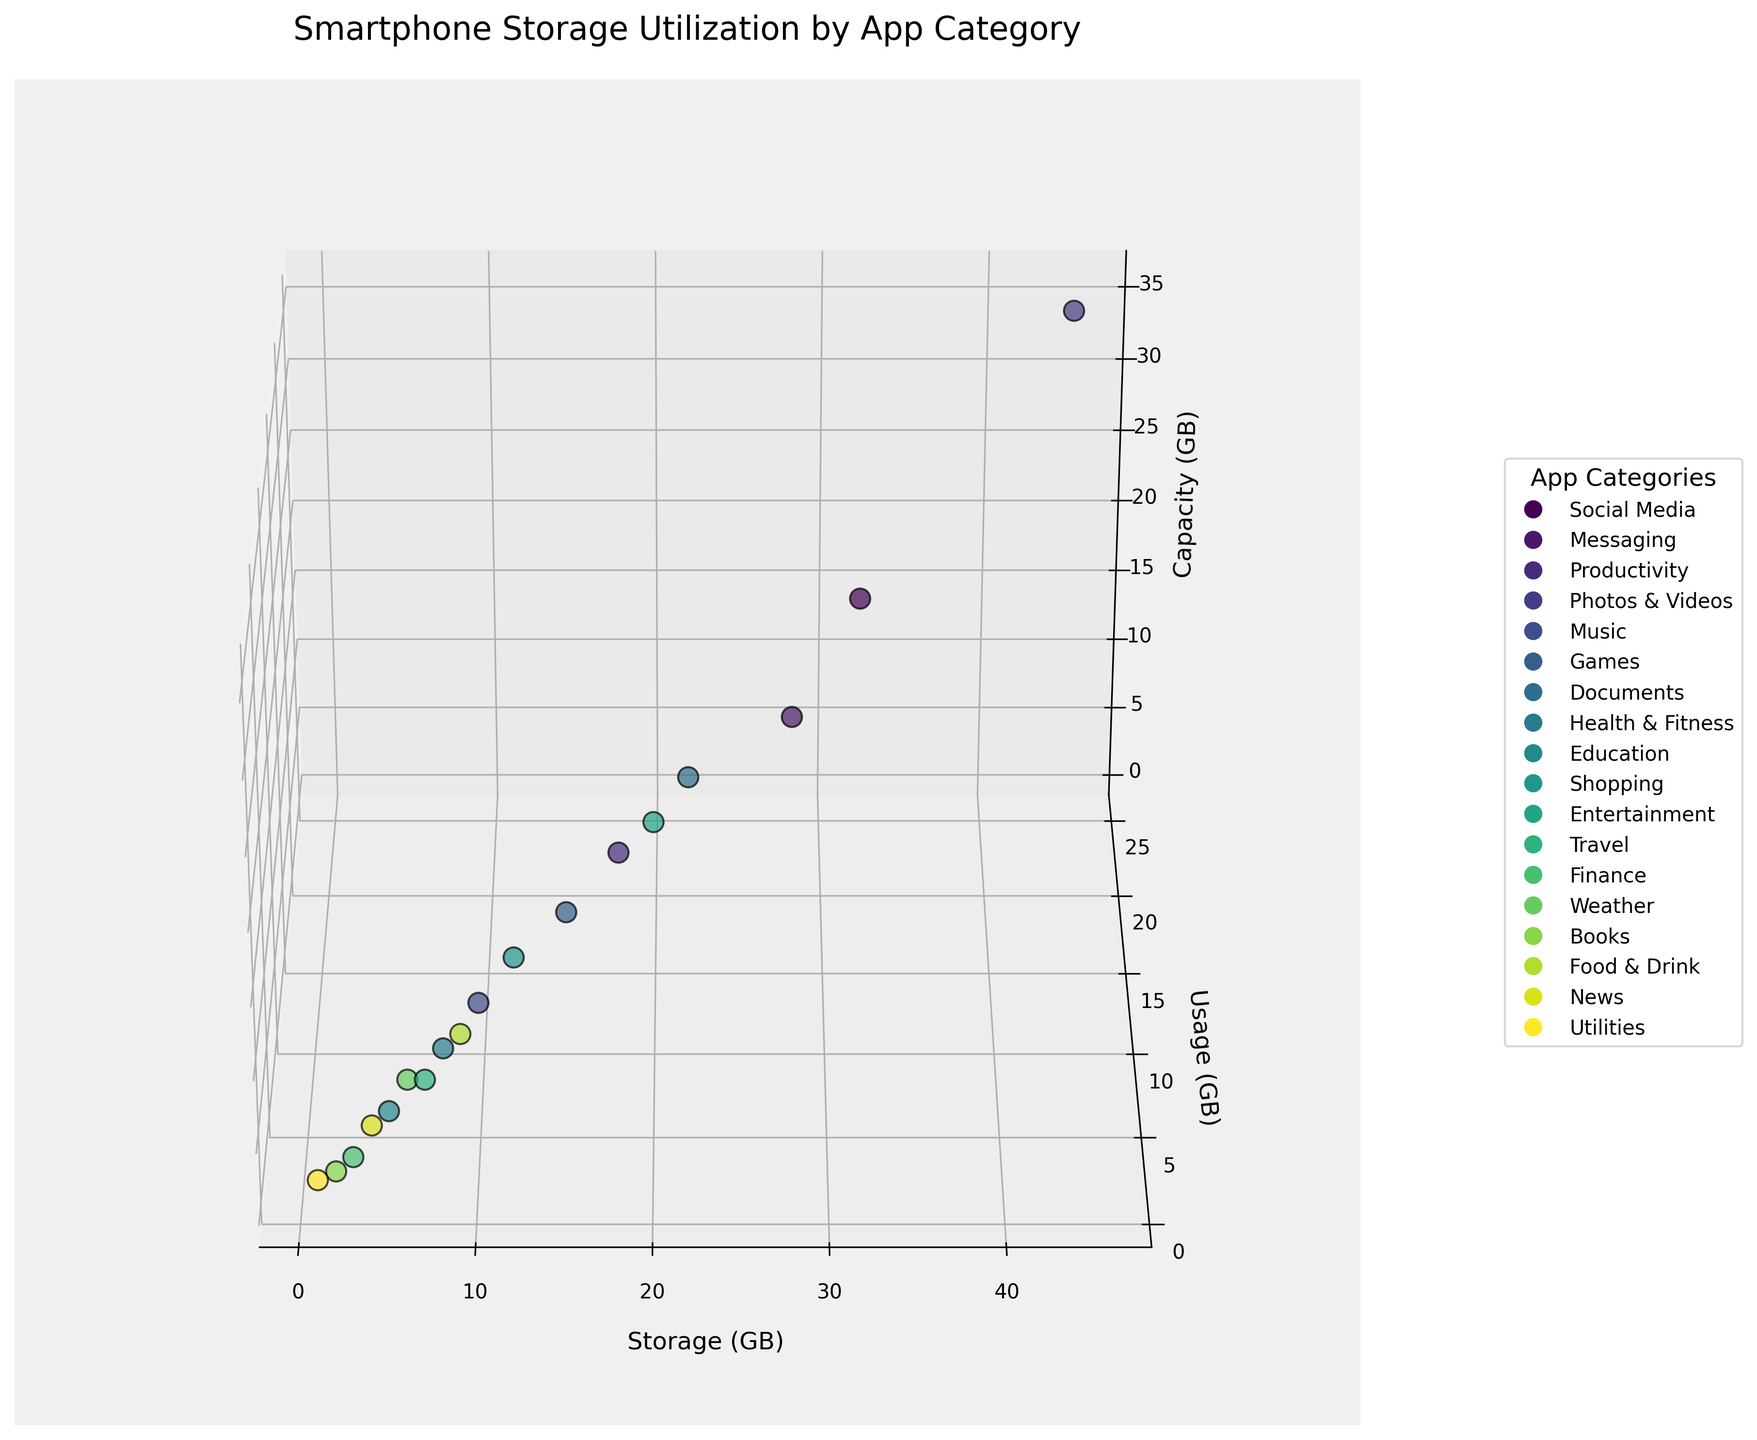What's the title of the figure? The title of the figure is located at the top of the plot, usually to provide a summary of what the plot is showing.
Answer: Smartphone Storage Utilization by App Category What are the axes labeled with? The axes labels provide information on what each axis represents in the figure. The x-axis is labeled "Storage (GB)," the y-axis is labeled "Usage (GB)," and the z-axis is labeled "Capacity (GB)."
Answer: Storage (GB), Usage (GB), Capacity (GB) How many data points are displayed in the figure? To find the number of data points, you can count the number of distinct points in the plot or refer to the categories given in the dataset.
Answer: 18 Which app category uses the most storage? Look for the category with the highest x-value, since storage is represented along the x-axis. "Photos & Videos" has the highest x-value of 45 GB.
Answer: Photos & Videos Compare the storage and usage between the "Social Media" and "Messaging" categories. For Social Media, the storage is 32 GB and usage is 15 GB. For Messaging, the storage is 28 GB and usage is 12 GB. Comparatively, Social Media uses 4 GB more storage and 3 GB more usage than Messaging.
Answer: Social Media uses more storage and usage What's the sum of storage for "Health & Fitness" and "Entertainment"? Add the storage values for "Health & Fitness" (8 GB) and "Entertainment" (20 GB). The sum is 8 + 20 = 28 GB.
Answer: 28 GB Which app category has the least capacity utilization? Capacity is represented by the z-axis. The "Utilities" category has a capacity of 1 GB, which is the least among all the categories.
Answer: Utilities Find the average usage for "Games," "Documents," and "Shopping" categories. Add the usage values for the categories and then divide by the number of categories. For Games (7 GB), Documents (10 GB), and Shopping (6 GB), the calculation is (7 + 10 + 6) / 3 = 23 / 3 ≈ 7.67 GB.
Answer: 7.67 GB Are there any categories where the storage equals the capacity? Scan through each data point to see if any values on the x-axis match the values on the z-axis. No categories have matching storage and capacity values in the dataset provided.
Answer: No How does the usage of "Productivity" compare to "Books"? The usage for "Productivity" is 8 GB, while for "Books" it is 1 GB. "Productivity" has 7 GB more usage than "Books."
Answer: Productivity uses more 